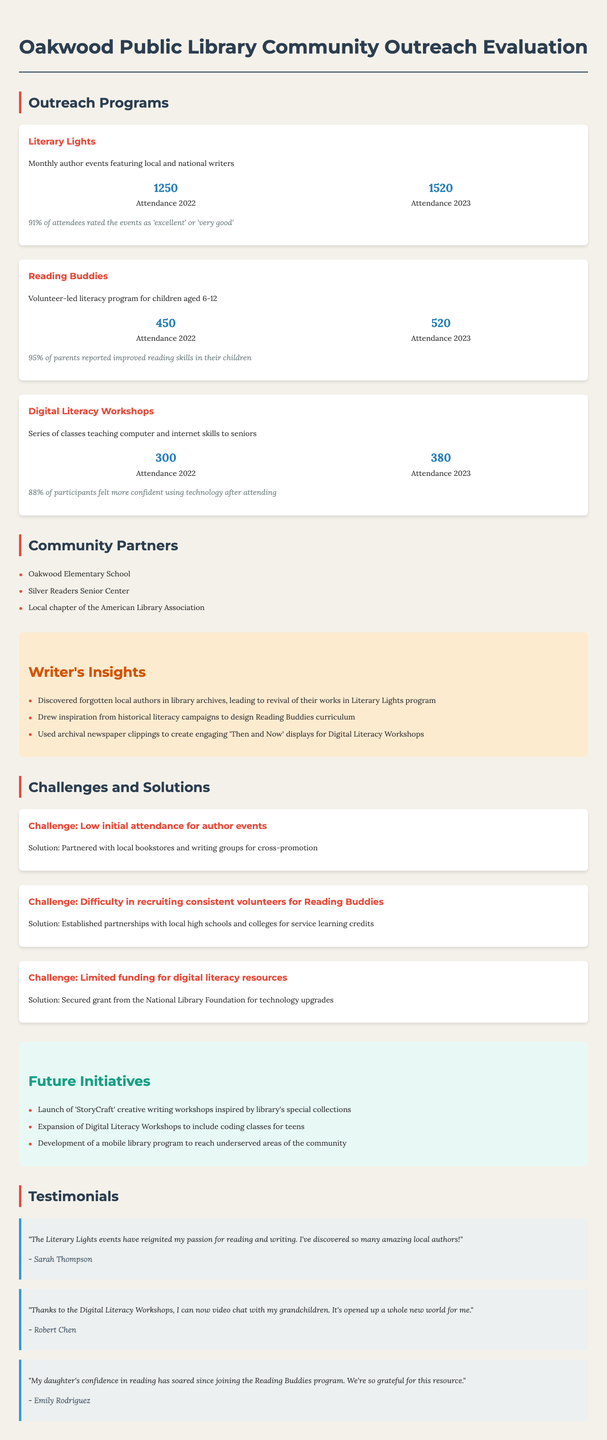what is the name of the literacy program for children? The document describes a literacy program called "Reading Buddies" aimed at children aged 6-12.
Answer: Reading Buddies who are three notable authors featured in the Literary Lights program? The program highlights local and national writers, including Celeste Ng, Colson Whitehead, and Louise Penny.
Answer: Celeste Ng, Colson Whitehead, Louise Penny what was the attendance for the Digital Literacy Workshops in 2023? According to the attendance statistics, the number of attendees for the Digital Literacy Workshops in 2023 was 380.
Answer: 380 what percentage of parents reported improved reading skills in their children through the Reading Buddies program? The document states that 95% of parents reported improved reading skills in their children as a result of participating in the program.
Answer: 95% what challenge did the library face regarding the author events? One of the challenges mentioned was "Low initial attendance for author events."
Answer: Low initial attendance for author events how many community partners are listed in the report? The document mentions three community partners involved in outreach efforts.
Answer: 3 what is one of the future initiatives planned for the library? The report outlines several future initiatives, including the launch of "StoryCraft" creative writing workshops.
Answer: StoryCraft what was the average reading level increase reported in the Reading Buddies program? The document indicates that the average reading level increased by 1.5 grades over a span of 6 months due to the program's efforts.
Answer: 1.5 grades who provided feedback stating they can now video chat with their grandchildren? The document features a testimonial from Robert Chen, who expressed gratitude for being able to video chat with his grandchildren after attending the Digital Literacy Workshops.
Answer: Robert Chen 